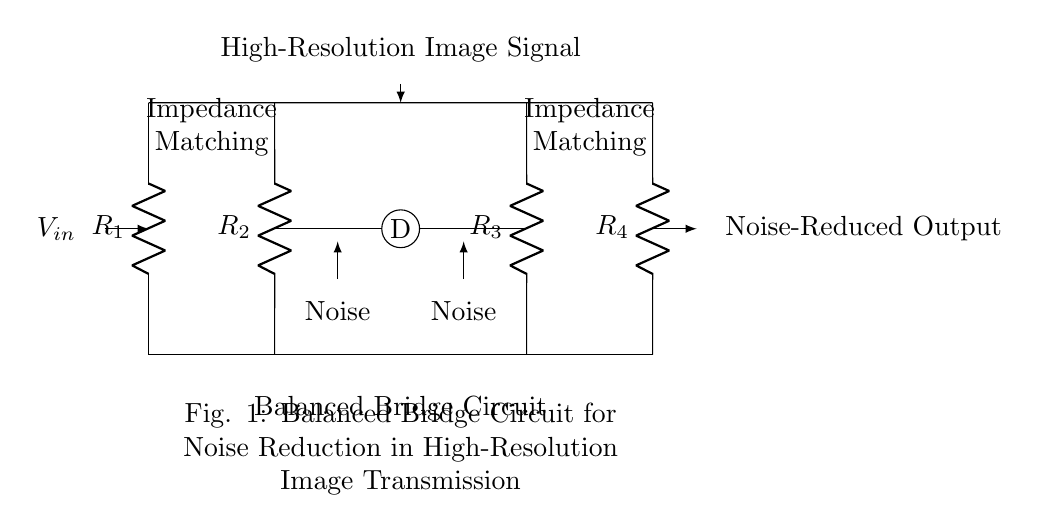What type of circuit is shown? The circuit is a balanced bridge circuit, which specifically is designed to minimize noise in high-resolution image transmission. It is characterized by its symmetrical arrangement and the use of impedance matching.
Answer: balanced bridge circuit How many resistors are in the circuit? The circuit contains four resistors, labeled as R1, R2, R3, and R4, which are strategically placed in the bridge configuration to achieve noise reduction.
Answer: four What is the purpose of the component labeled 'D'? The component labeled 'D' acts as a differential node, where the balanced signals converge, allowing for the noise reduction effect of the bridge. It helps in maintaining the integrity of the image signal.
Answer: differential node What do the nodes labeled 'Noise' represent? The nodes labeled 'Noise' signify the points in the circuit where extraneous electrical interference or unwanted signals may be present, which the balanced bridge aims to minimize.
Answer: unwanted signals What is indicated by the label 'Impedance Matching'? The label 'Impedance Matching' suggests that the resistors R1, R2, R3, and R4 are arranged to match the impedance of the circuit with the source and load, thereby optimizing signal transmission and reducing reflections.
Answer: optimized signal transmission What does the arrow pointing towards 'Noise-Reduced Output' signify? The arrow indicates the direction of the output signal, which has been processed through the balanced bridge and is expected to have significantly reduced noise compared to the input signal.
Answer: direction of noise-reduced output What is the main application of this balanced bridge circuit? The main application of this balanced bridge circuit is in high-resolution image transmission, where maintaining signal quality and minimizing noise is crucial for clear imagery.
Answer: high-resolution image transmission 